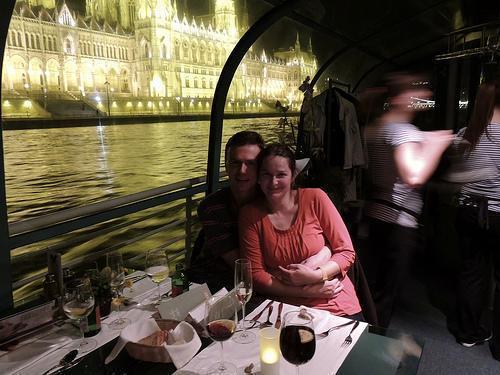How many people are visible and in focus?
Give a very brief answer. 4. How many wine glasses are in the image?
Give a very brief answer. 6. 